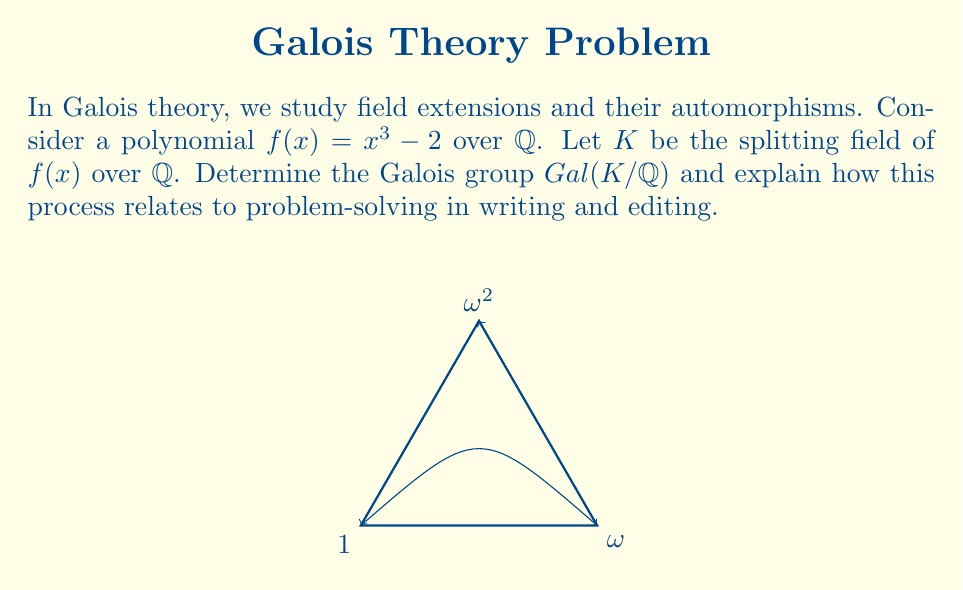Show me your answer to this math problem. Let's approach this step-by-step:

1) First, we need to find the roots of $f(x) = x^3 - 2$. The roots are:
   $$\sqrt[3]{2}, \omega\sqrt[3]{2}, \omega^2\sqrt[3]{2}$$
   where $\omega = e^{2\pi i/3} = -\frac{1}{2} + i\frac{\sqrt{3}}{2}$ is a primitive cube root of unity.

2) The splitting field $K$ is $\mathbb{Q}(\sqrt[3]{2}, \omega)$.

3) To find the Galois group, we need to determine the automorphisms of $K$ that fix $\mathbb{Q}$.

4) There are 6 such automorphisms, corresponding to the permutations of the roots:
   $$\begin{align*}
   \sigma_1 &: \sqrt[3]{2} \mapsto \sqrt[3]{2}, \omega \mapsto \omega \\
   \sigma_2 &: \sqrt[3]{2} \mapsto \omega\sqrt[3]{2}, \omega \mapsto \omega \\
   \sigma_3 &: \sqrt[3]{2} \mapsto \omega^2\sqrt[3]{2}, \omega \mapsto \omega \\
   \sigma_4 &: \sqrt[3]{2} \mapsto \sqrt[3]{2}, \omega \mapsto \omega^2 \\
   \sigma_5 &: \sqrt[3]{2} \mapsto \omega\sqrt[3]{2}, \omega \mapsto \omega^2 \\
   \sigma_6 &: \sqrt[3]{2} \mapsto \omega^2\sqrt[3]{2}, \omega \mapsto \omega^2
   \end{align*}$$

5) These automorphisms form a group isomorphic to $S_3$, the symmetric group on 3 elements.

6) Therefore, $Gal(K/\mathbb{Q}) \cong S_3$.

Relation to writing and editing:
This process parallels problem-solving in writing and editing in several ways:

a) Identifying the core elements (roots of the polynomial ≈ key ideas in writing)
b) Understanding the relationships between these elements (field extension ≈ structure of the text)
c) Exploring different arrangements (automorphisms ≈ different ways to present information)
d) Finding the underlying structure (Galois group ≈ core message or theme)
e) Simplifying complex ideas into a concise form (isomorphism to $S_3$ ≈ clear, concise writing)

Just as Galois theory reveals the deep structure of polynomial equations, effective writing and editing uncover and clarify the underlying structure of ideas.
Answer: $Gal(K/\mathbb{Q}) \cong S_3$ 